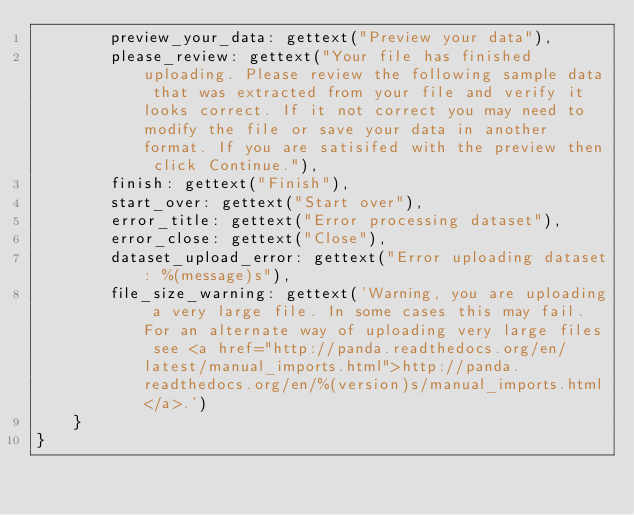<code> <loc_0><loc_0><loc_500><loc_500><_JavaScript_>        preview_your_data: gettext("Preview your data"),
        please_review: gettext("Your file has finished uploading. Please review the following sample data that was extracted from your file and verify it looks correct. If it not correct you may need to modify the file or save your data in another format. If you are satisifed with the preview then click Continue."),
        finish: gettext("Finish"),
        start_over: gettext("Start over"),
        error_title: gettext("Error processing dataset"),
        error_close: gettext("Close"),
        dataset_upload_error: gettext("Error uploading dataset: %(message)s"),
        file_size_warning: gettext('Warning, you are uploading a very large file. In some cases this may fail. For an alternate way of uploading very large files see <a href="http://panda.readthedocs.org/en/latest/manual_imports.html">http://panda.readthedocs.org/en/%(version)s/manual_imports.html</a>.')
    }
}
</code> 